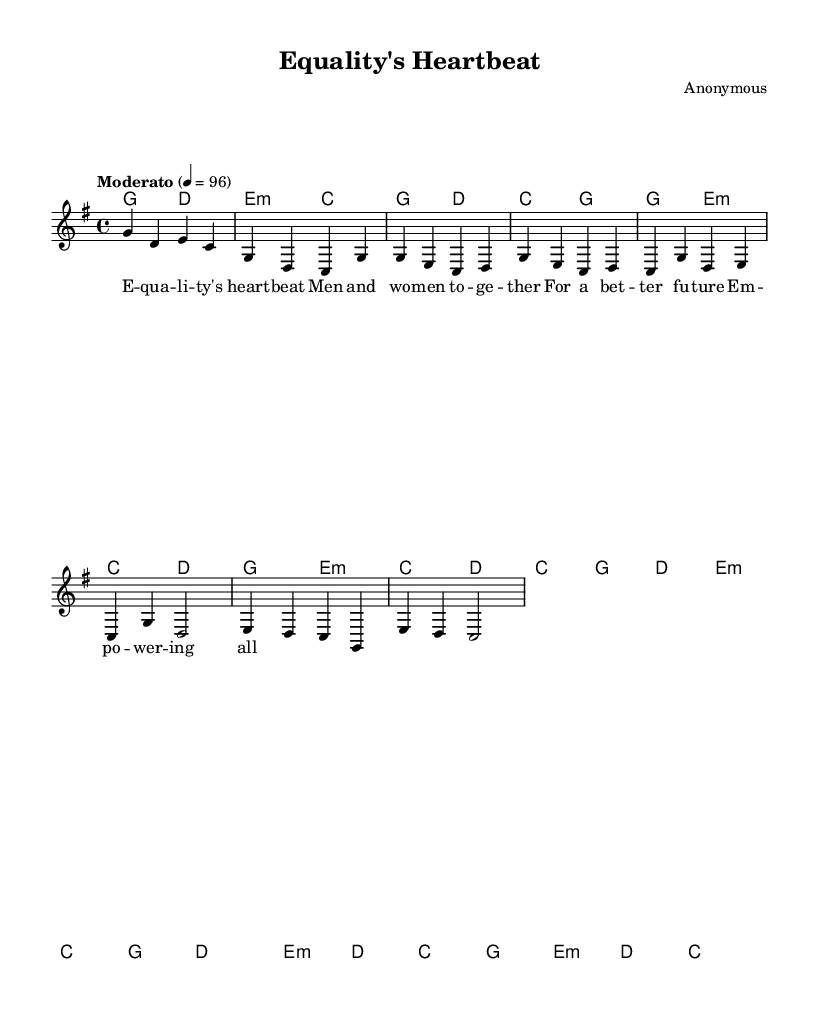What is the key signature of this music? The key signature shown in the music is G major, which has one sharp (F#). You can identify the key signature by looking at the beginning of the staff, where it is indicated.
Answer: G major What is the time signature of the piece? The time signature indicated on the staff is 4/4. This means there are four beats in each measure, and the quarter note gets one beat. You can find the time signature at the beginning of the score.
Answer: 4/4 What is the tempo marking for this piece? The tempo marking shown in the music is "Moderato" at 96 beats per minute. The term "Moderato" indicates a moderate pace. You can see this at the beginning of the piece, where the tempo is specified.
Answer: Moderato 4 = 96 How many measures are in the piece? The piece consists of a total of 12 measures, which can be counted from the beginning to the end of the score. Each measure is separated by vertical lines called bar lines, making it easy to count them.
Answer: 12 What are the first two chords of the piece? The first two chords in the score are G major and D major. You can identify the chords by looking at the chord symbols placed above the staff at the beginning of the piece.
Answer: G, D What lyrical theme is emphasized in the song? The lyrical theme focuses on equality, specifically highlighting the unity of men and women for a better future. This is evident from the provided lyrics that mention "equality's heartbeat" and "empowering all."
Answer: Equality What style of music does this sheet represent? This sheet music represents contemporary acoustic folk music. This is determined by its acoustic instrumentation, lyrical content promoting social issues, and its folk-style melody and chord progressions.
Answer: Folk 